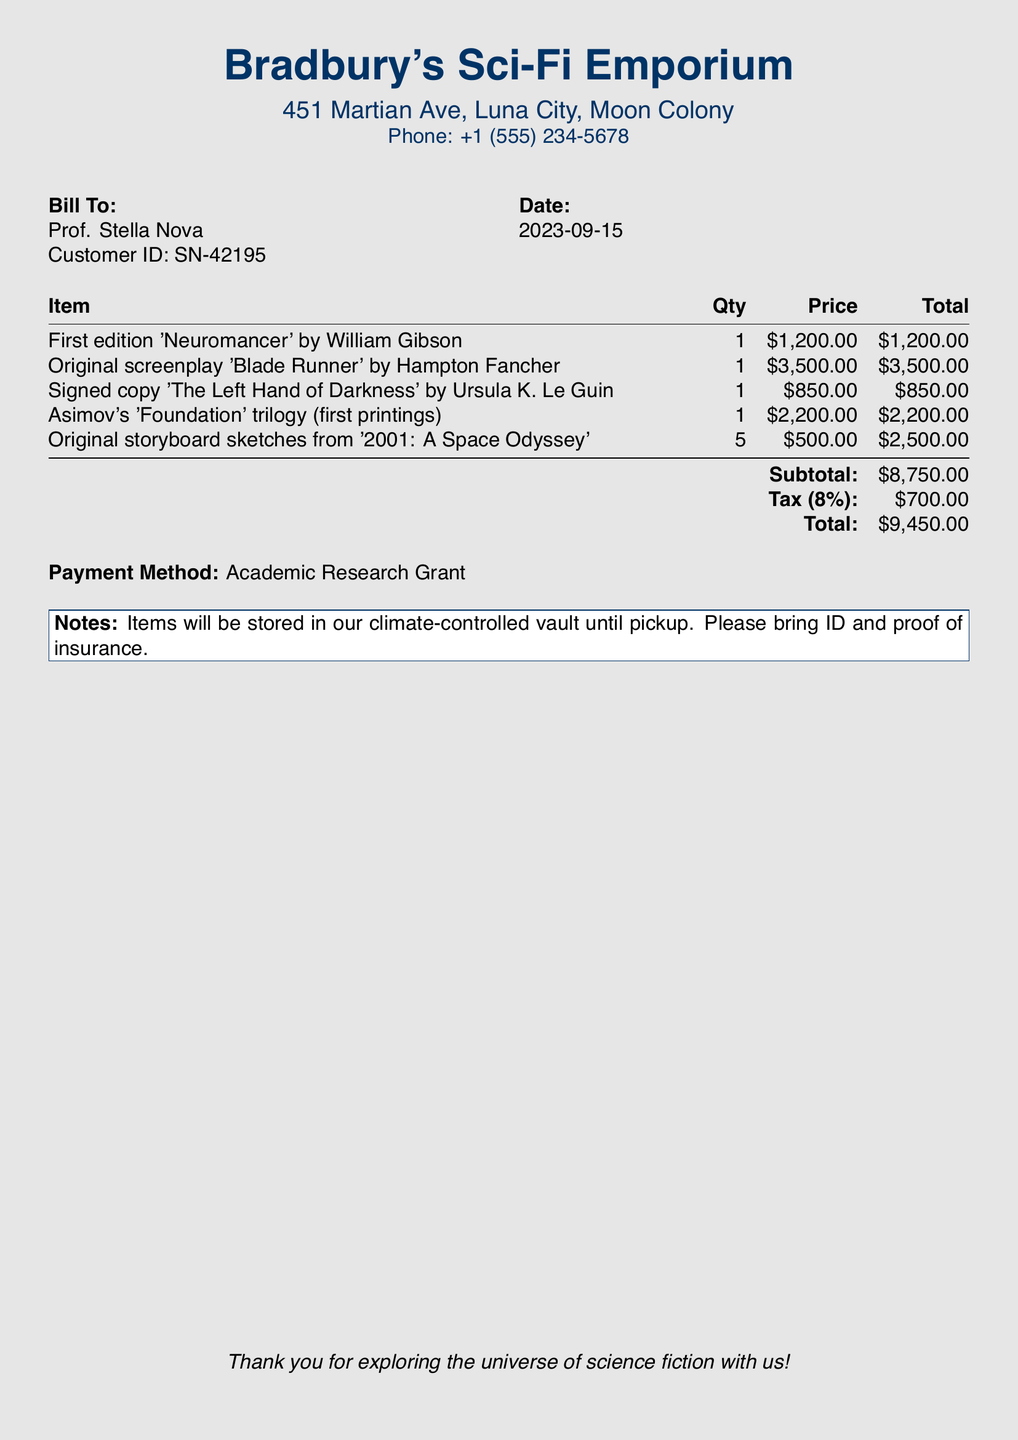What is the date of the transaction? The date of the transaction is printed clearly in the document.
Answer: 2023-09-15 Who is the customer? The document provides the name of the individual billed.
Answer: Prof. Stella Nova How many items were purchased? The document lists all the items purchased, which can be totaled.
Answer: 6 What is the price of the signed copy of 'The Left Hand of Darkness'? The price is indicated next to the specific item in the bill.
Answer: $850.00 What is the subtotal amount? The subtotal amount is the total of all items before tax is added, stated in the document.
Answer: $8,750.00 What payment method was used? The payment method is specified clearly in the bill.
Answer: Academic Research Grant What is the tax percentage applied? The document states the tax percentage applied to the subtotal.
Answer: 8% What quantity of original storyboard sketches was purchased? The bill specifies the quantity for that particular item.
Answer: 5 What is the total amount due? The total amount due is calculated at the end of the bill and is a key piece of information.
Answer: $9,450.00 